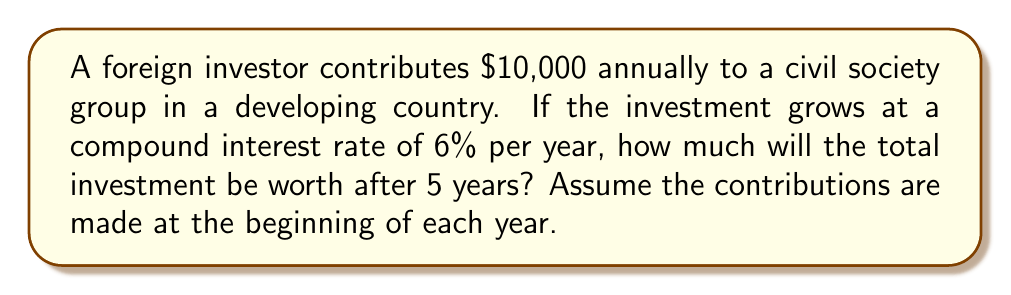Give your solution to this math problem. Let's approach this step-by-step using the compound interest formula for annual contributions:

1) The formula for compound interest with annual contributions is:
   $$A = P \cdot \frac{(1+r)^n - 1}{r} \cdot (1+r)$$
   where:
   A = final amount
   P = annual contribution
   r = annual interest rate
   n = number of years

2) Given:
   P = $10,000
   r = 6% = 0.06
   n = 5 years

3) Plugging these values into the formula:
   $$A = 10000 \cdot \frac{(1+0.06)^5 - 1}{0.06} \cdot (1+0.06)$$

4) Let's calculate step by step:
   $$(1+0.06)^5 = 1.33823069$$
   
   $$\frac{1.33823069 - 1}{0.06} = 5.63717817$$
   
   $$5.63717817 \cdot (1+0.06) = 5.97540886$$

5) Now, multiply by the annual contribution:
   $$A = 10000 \cdot 5.97540886 = 59754.0886$$

6) Rounding to the nearest cent:
   $$A = $59,754.09$$
Answer: $59,754.09 